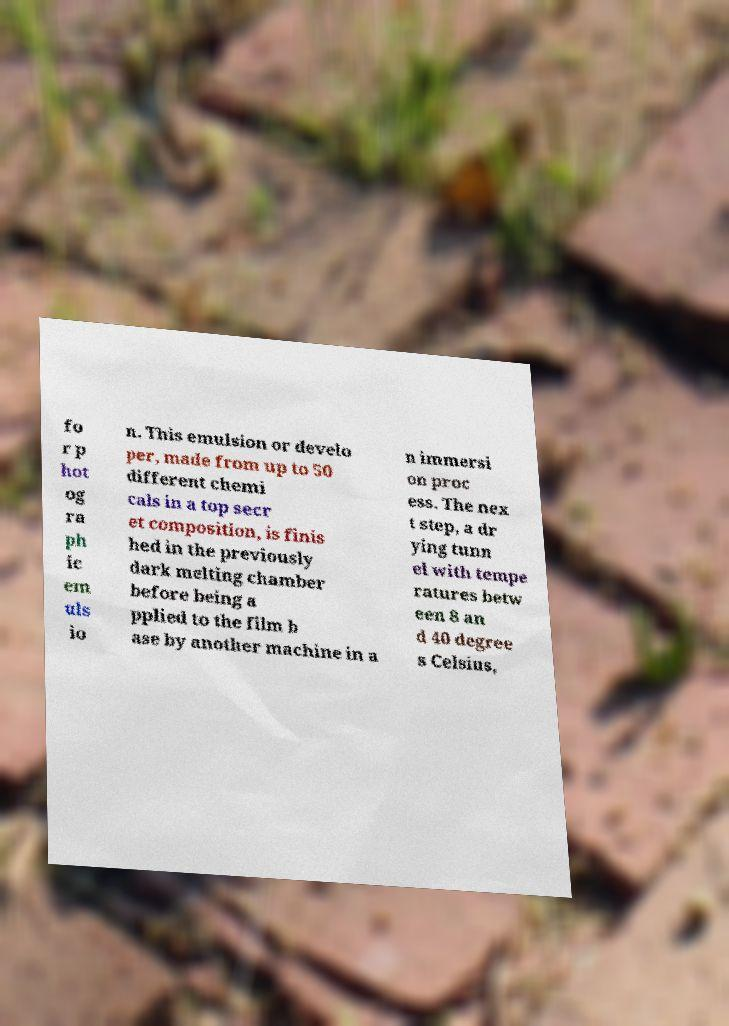Could you assist in decoding the text presented in this image and type it out clearly? fo r p hot og ra ph ic em uls io n. This emulsion or develo per, made from up to 50 different chemi cals in a top secr et composition, is finis hed in the previously dark melting chamber before being a pplied to the film b ase by another machine in a n immersi on proc ess. The nex t step, a dr ying tunn el with tempe ratures betw een 8 an d 40 degree s Celsius, 